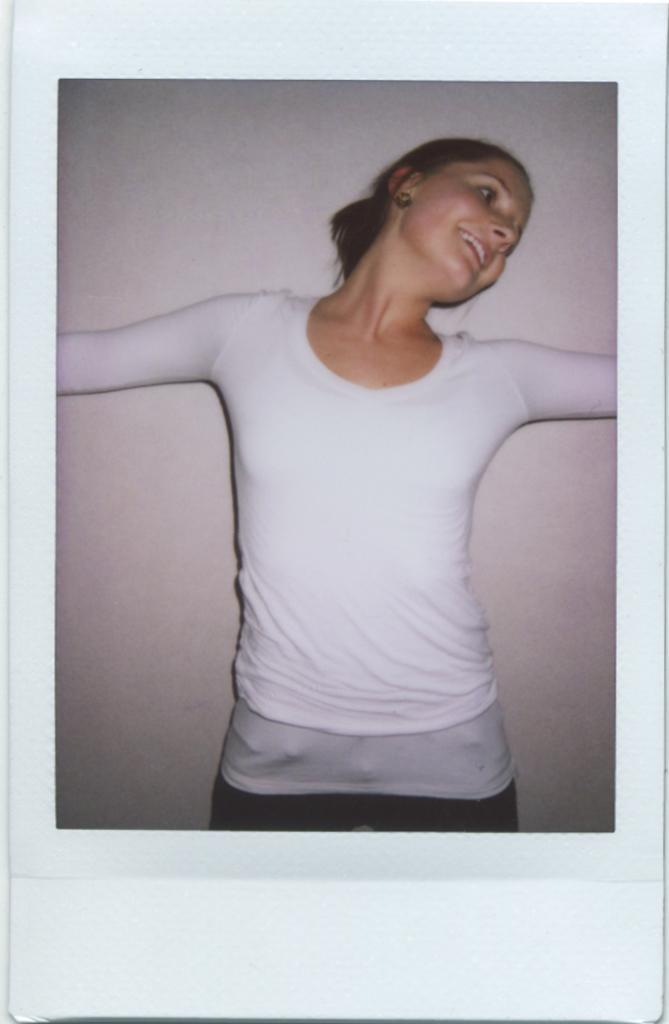How would you summarize this image in a sentence or two? This is a photograph. In the photo we can see a woman is standing and behind her we can see the wall. 